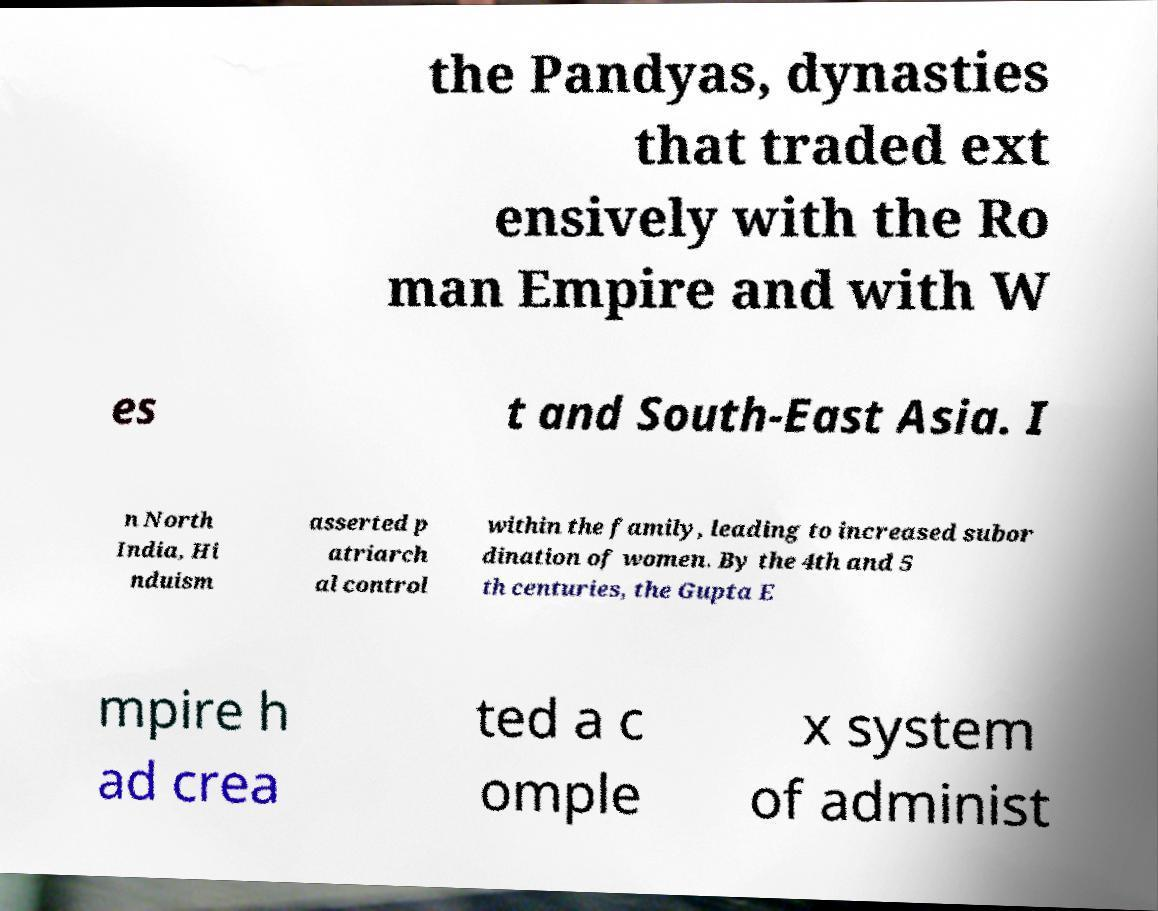Please identify and transcribe the text found in this image. the Pandyas, dynasties that traded ext ensively with the Ro man Empire and with W es t and South-East Asia. I n North India, Hi nduism asserted p atriarch al control within the family, leading to increased subor dination of women. By the 4th and 5 th centuries, the Gupta E mpire h ad crea ted a c omple x system of administ 